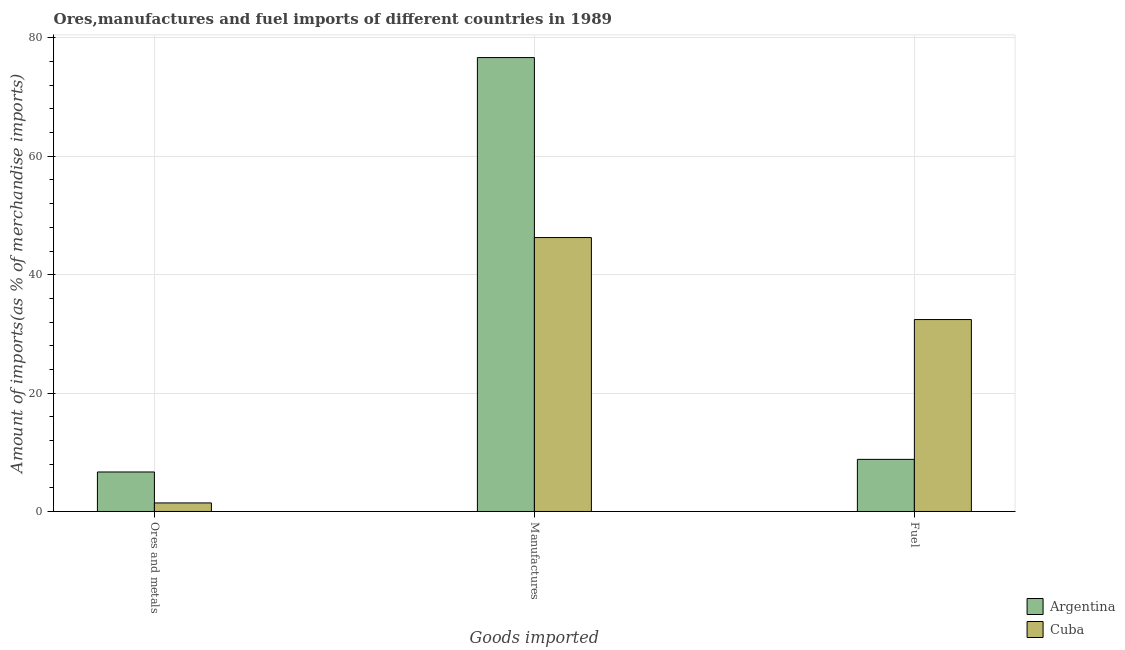How many different coloured bars are there?
Offer a very short reply. 2. How many groups of bars are there?
Your answer should be very brief. 3. Are the number of bars on each tick of the X-axis equal?
Make the answer very short. Yes. What is the label of the 2nd group of bars from the left?
Your answer should be very brief. Manufactures. What is the percentage of fuel imports in Cuba?
Make the answer very short. 32.42. Across all countries, what is the maximum percentage of ores and metals imports?
Your answer should be very brief. 6.67. Across all countries, what is the minimum percentage of fuel imports?
Give a very brief answer. 8.8. In which country was the percentage of fuel imports maximum?
Make the answer very short. Cuba. In which country was the percentage of ores and metals imports minimum?
Your answer should be compact. Cuba. What is the total percentage of ores and metals imports in the graph?
Offer a very short reply. 8.12. What is the difference between the percentage of fuel imports in Argentina and that in Cuba?
Give a very brief answer. -23.62. What is the difference between the percentage of manufactures imports in Cuba and the percentage of fuel imports in Argentina?
Make the answer very short. 37.47. What is the average percentage of ores and metals imports per country?
Provide a short and direct response. 4.06. What is the difference between the percentage of manufactures imports and percentage of fuel imports in Cuba?
Provide a short and direct response. 13.85. In how many countries, is the percentage of manufactures imports greater than 40 %?
Provide a succinct answer. 2. What is the ratio of the percentage of manufactures imports in Cuba to that in Argentina?
Keep it short and to the point. 0.6. Is the difference between the percentage of manufactures imports in Cuba and Argentina greater than the difference between the percentage of ores and metals imports in Cuba and Argentina?
Provide a succinct answer. No. What is the difference between the highest and the second highest percentage of fuel imports?
Give a very brief answer. 23.62. What is the difference between the highest and the lowest percentage of manufactures imports?
Your response must be concise. 30.4. In how many countries, is the percentage of ores and metals imports greater than the average percentage of ores and metals imports taken over all countries?
Give a very brief answer. 1. Is the sum of the percentage of manufactures imports in Argentina and Cuba greater than the maximum percentage of ores and metals imports across all countries?
Offer a terse response. Yes. What does the 1st bar from the right in Ores and metals represents?
Keep it short and to the point. Cuba. Is it the case that in every country, the sum of the percentage of ores and metals imports and percentage of manufactures imports is greater than the percentage of fuel imports?
Provide a short and direct response. Yes. How many bars are there?
Provide a succinct answer. 6. What is the difference between two consecutive major ticks on the Y-axis?
Provide a short and direct response. 20. Does the graph contain any zero values?
Ensure brevity in your answer.  No. Where does the legend appear in the graph?
Ensure brevity in your answer.  Bottom right. How many legend labels are there?
Give a very brief answer. 2. How are the legend labels stacked?
Your answer should be compact. Vertical. What is the title of the graph?
Provide a succinct answer. Ores,manufactures and fuel imports of different countries in 1989. Does "Syrian Arab Republic" appear as one of the legend labels in the graph?
Keep it short and to the point. No. What is the label or title of the X-axis?
Ensure brevity in your answer.  Goods imported. What is the label or title of the Y-axis?
Provide a succinct answer. Amount of imports(as % of merchandise imports). What is the Amount of imports(as % of merchandise imports) of Argentina in Ores and metals?
Your answer should be very brief. 6.67. What is the Amount of imports(as % of merchandise imports) of Cuba in Ores and metals?
Offer a very short reply. 1.45. What is the Amount of imports(as % of merchandise imports) in Argentina in Manufactures?
Your response must be concise. 76.67. What is the Amount of imports(as % of merchandise imports) of Cuba in Manufactures?
Offer a very short reply. 46.27. What is the Amount of imports(as % of merchandise imports) in Argentina in Fuel?
Make the answer very short. 8.8. What is the Amount of imports(as % of merchandise imports) of Cuba in Fuel?
Offer a very short reply. 32.42. Across all Goods imported, what is the maximum Amount of imports(as % of merchandise imports) in Argentina?
Provide a succinct answer. 76.67. Across all Goods imported, what is the maximum Amount of imports(as % of merchandise imports) of Cuba?
Provide a succinct answer. 46.27. Across all Goods imported, what is the minimum Amount of imports(as % of merchandise imports) of Argentina?
Your answer should be compact. 6.67. Across all Goods imported, what is the minimum Amount of imports(as % of merchandise imports) of Cuba?
Ensure brevity in your answer.  1.45. What is the total Amount of imports(as % of merchandise imports) in Argentina in the graph?
Ensure brevity in your answer.  92.15. What is the total Amount of imports(as % of merchandise imports) of Cuba in the graph?
Ensure brevity in your answer.  80.14. What is the difference between the Amount of imports(as % of merchandise imports) in Argentina in Ores and metals and that in Manufactures?
Offer a terse response. -70. What is the difference between the Amount of imports(as % of merchandise imports) of Cuba in Ores and metals and that in Manufactures?
Provide a short and direct response. -44.82. What is the difference between the Amount of imports(as % of merchandise imports) of Argentina in Ores and metals and that in Fuel?
Keep it short and to the point. -2.13. What is the difference between the Amount of imports(as % of merchandise imports) in Cuba in Ores and metals and that in Fuel?
Give a very brief answer. -30.97. What is the difference between the Amount of imports(as % of merchandise imports) in Argentina in Manufactures and that in Fuel?
Ensure brevity in your answer.  67.87. What is the difference between the Amount of imports(as % of merchandise imports) in Cuba in Manufactures and that in Fuel?
Your answer should be compact. 13.85. What is the difference between the Amount of imports(as % of merchandise imports) of Argentina in Ores and metals and the Amount of imports(as % of merchandise imports) of Cuba in Manufactures?
Your response must be concise. -39.6. What is the difference between the Amount of imports(as % of merchandise imports) in Argentina in Ores and metals and the Amount of imports(as % of merchandise imports) in Cuba in Fuel?
Provide a short and direct response. -25.75. What is the difference between the Amount of imports(as % of merchandise imports) in Argentina in Manufactures and the Amount of imports(as % of merchandise imports) in Cuba in Fuel?
Ensure brevity in your answer.  44.25. What is the average Amount of imports(as % of merchandise imports) in Argentina per Goods imported?
Make the answer very short. 30.72. What is the average Amount of imports(as % of merchandise imports) in Cuba per Goods imported?
Make the answer very short. 26.71. What is the difference between the Amount of imports(as % of merchandise imports) of Argentina and Amount of imports(as % of merchandise imports) of Cuba in Ores and metals?
Your answer should be compact. 5.23. What is the difference between the Amount of imports(as % of merchandise imports) of Argentina and Amount of imports(as % of merchandise imports) of Cuba in Manufactures?
Offer a very short reply. 30.4. What is the difference between the Amount of imports(as % of merchandise imports) of Argentina and Amount of imports(as % of merchandise imports) of Cuba in Fuel?
Provide a short and direct response. -23.62. What is the ratio of the Amount of imports(as % of merchandise imports) of Argentina in Ores and metals to that in Manufactures?
Provide a short and direct response. 0.09. What is the ratio of the Amount of imports(as % of merchandise imports) of Cuba in Ores and metals to that in Manufactures?
Your answer should be very brief. 0.03. What is the ratio of the Amount of imports(as % of merchandise imports) of Argentina in Ores and metals to that in Fuel?
Offer a very short reply. 0.76. What is the ratio of the Amount of imports(as % of merchandise imports) of Cuba in Ores and metals to that in Fuel?
Keep it short and to the point. 0.04. What is the ratio of the Amount of imports(as % of merchandise imports) in Argentina in Manufactures to that in Fuel?
Keep it short and to the point. 8.71. What is the ratio of the Amount of imports(as % of merchandise imports) in Cuba in Manufactures to that in Fuel?
Your answer should be compact. 1.43. What is the difference between the highest and the second highest Amount of imports(as % of merchandise imports) of Argentina?
Your answer should be compact. 67.87. What is the difference between the highest and the second highest Amount of imports(as % of merchandise imports) of Cuba?
Your response must be concise. 13.85. What is the difference between the highest and the lowest Amount of imports(as % of merchandise imports) of Argentina?
Your response must be concise. 70. What is the difference between the highest and the lowest Amount of imports(as % of merchandise imports) in Cuba?
Offer a terse response. 44.82. 